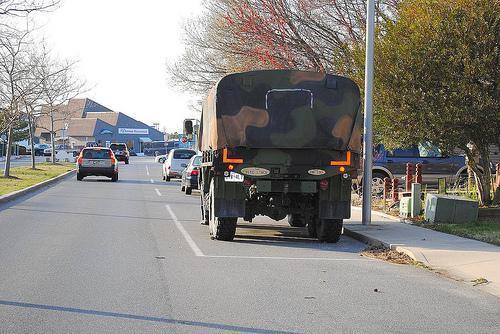How many army trucks are visible?
Give a very brief answer. 1. 